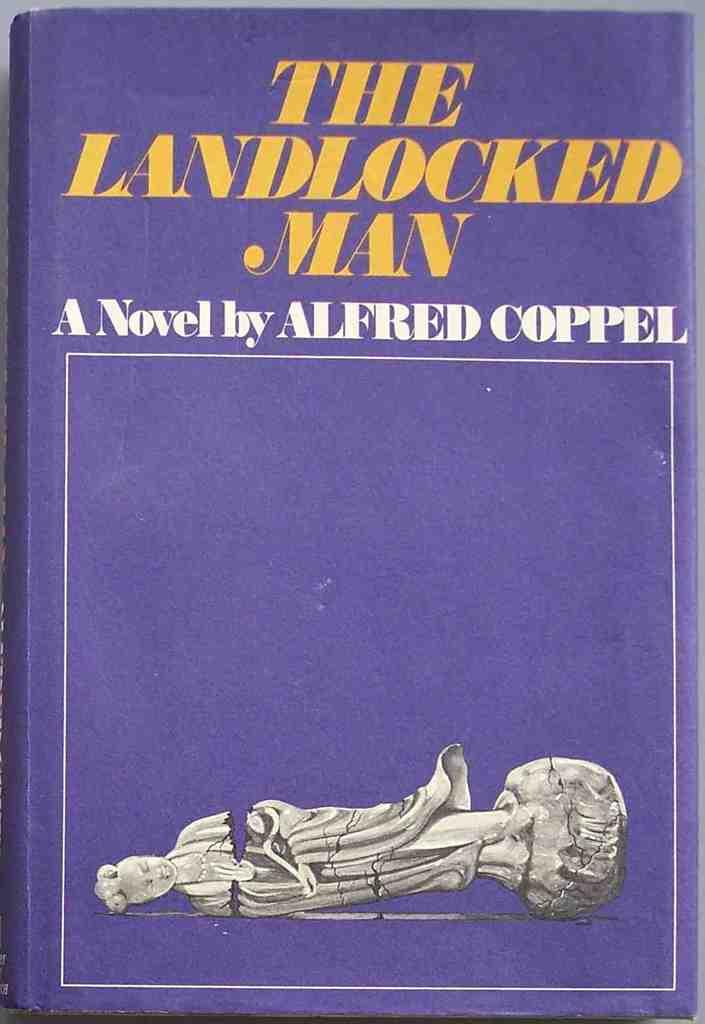<image>
Create a compact narrative representing the image presented. An Alfred Coppel novel that pictures a broken statue on the cover. 